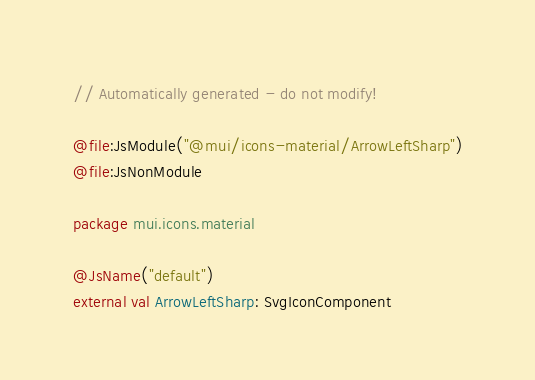<code> <loc_0><loc_0><loc_500><loc_500><_Kotlin_>// Automatically generated - do not modify!

@file:JsModule("@mui/icons-material/ArrowLeftSharp")
@file:JsNonModule

package mui.icons.material

@JsName("default")
external val ArrowLeftSharp: SvgIconComponent
</code> 